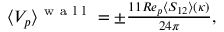Convert formula to latex. <formula><loc_0><loc_0><loc_500><loc_500>\begin{array} { r } { \langle V _ { p } \rangle ^ { w a l l } = \pm \frac { 1 1 R e _ { p } \langle S _ { 1 2 } \rangle ( \kappa ) } { 2 4 \pi } , } \end{array}</formula> 